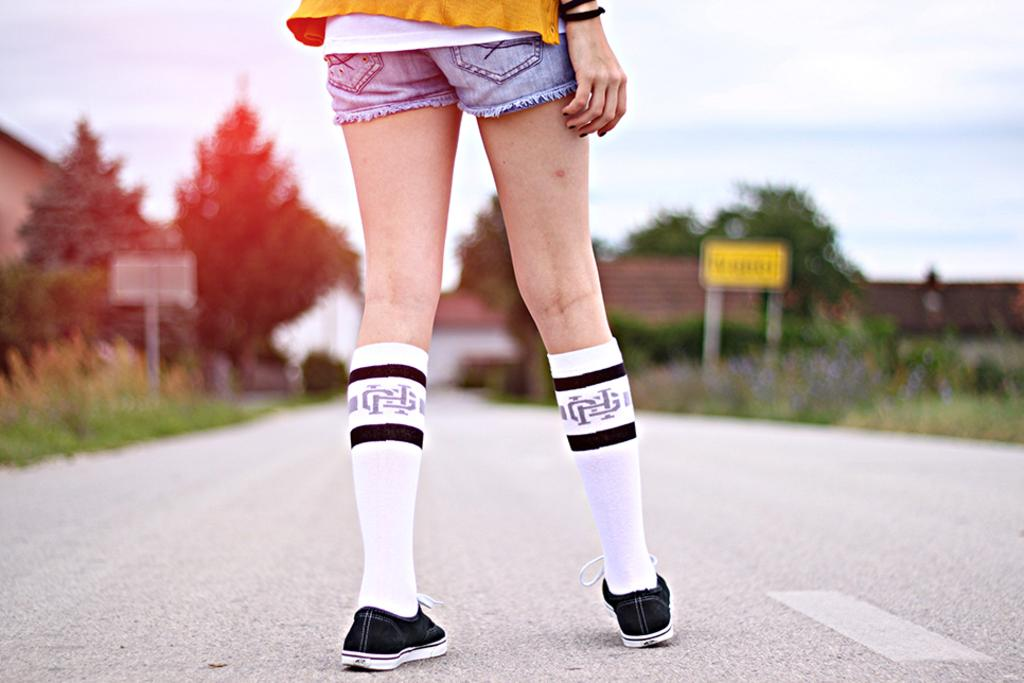Who or what is in the front of the image? There is a person in the front of the image. What can be seen in the background of the image? There are trees, houses, grass, and boards in the background of the image. What is visible at the top of the image? The sky is visible at the top of the image. What type of pig can be seen taking a voyage in the image? There is no pig or voyage present in the image. 